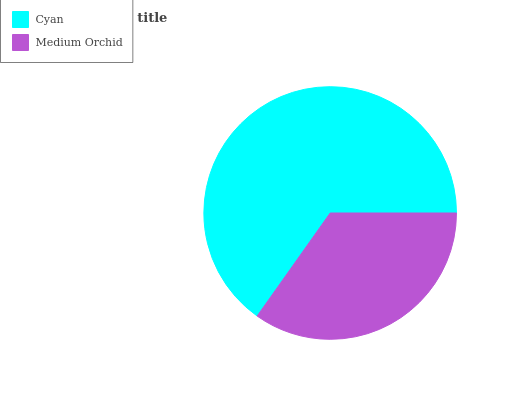Is Medium Orchid the minimum?
Answer yes or no. Yes. Is Cyan the maximum?
Answer yes or no. Yes. Is Medium Orchid the maximum?
Answer yes or no. No. Is Cyan greater than Medium Orchid?
Answer yes or no. Yes. Is Medium Orchid less than Cyan?
Answer yes or no. Yes. Is Medium Orchid greater than Cyan?
Answer yes or no. No. Is Cyan less than Medium Orchid?
Answer yes or no. No. Is Cyan the high median?
Answer yes or no. Yes. Is Medium Orchid the low median?
Answer yes or no. Yes. Is Medium Orchid the high median?
Answer yes or no. No. Is Cyan the low median?
Answer yes or no. No. 